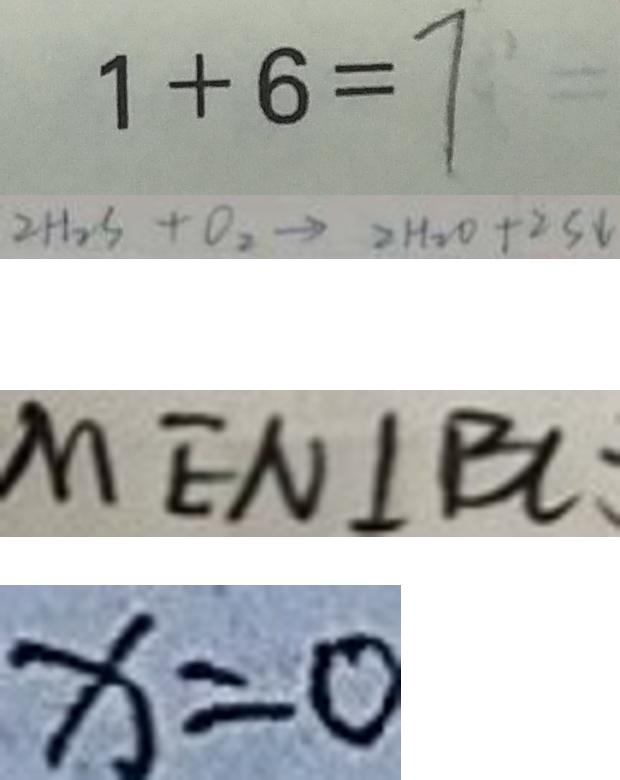<formula> <loc_0><loc_0><loc_500><loc_500>1 + 6 = 7 
 2 H _ { 2 } S + O _ { 2 } \rightarrow 2 H _ { 2 } O + 2 S \downarrow 
 M E N \bot B A 
 x = 0</formula> 